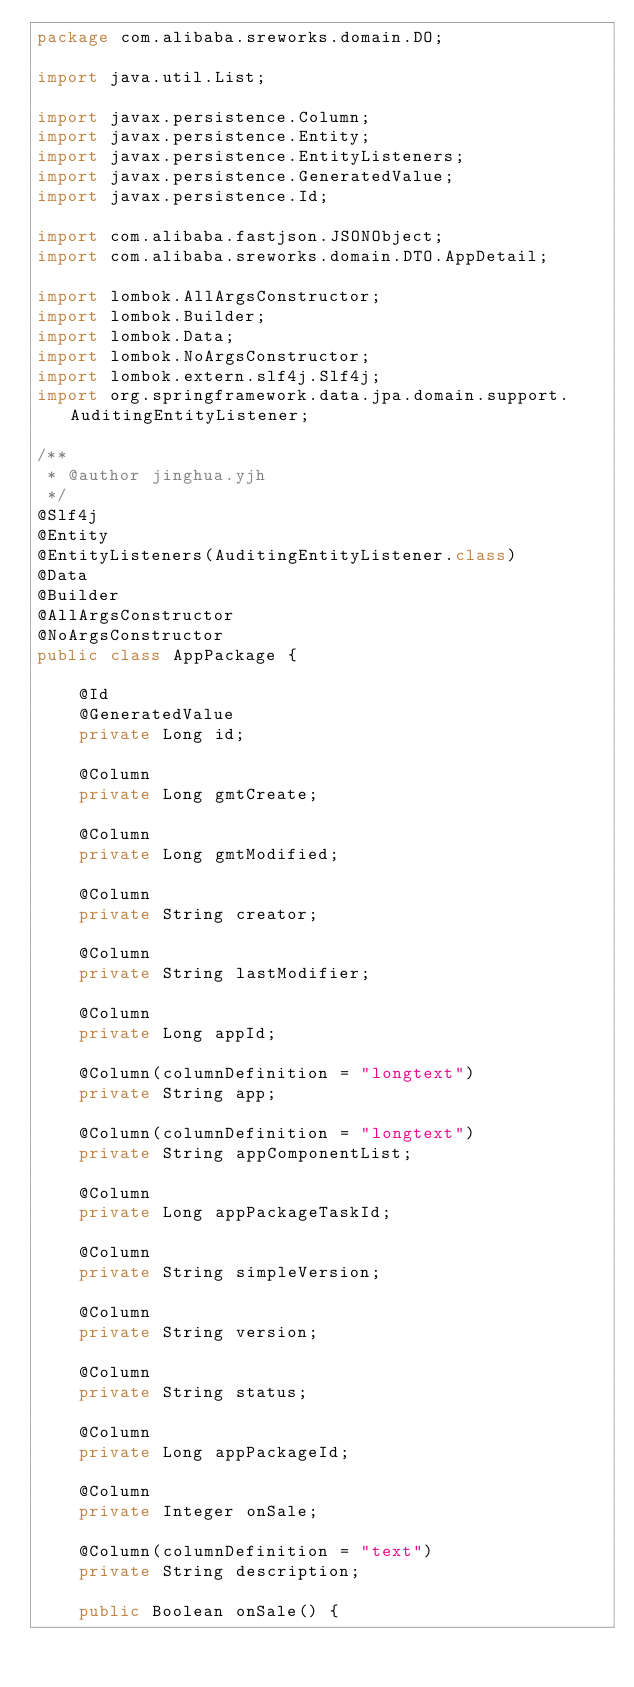Convert code to text. <code><loc_0><loc_0><loc_500><loc_500><_Java_>package com.alibaba.sreworks.domain.DO;

import java.util.List;

import javax.persistence.Column;
import javax.persistence.Entity;
import javax.persistence.EntityListeners;
import javax.persistence.GeneratedValue;
import javax.persistence.Id;

import com.alibaba.fastjson.JSONObject;
import com.alibaba.sreworks.domain.DTO.AppDetail;

import lombok.AllArgsConstructor;
import lombok.Builder;
import lombok.Data;
import lombok.NoArgsConstructor;
import lombok.extern.slf4j.Slf4j;
import org.springframework.data.jpa.domain.support.AuditingEntityListener;

/**
 * @author jinghua.yjh
 */
@Slf4j
@Entity
@EntityListeners(AuditingEntityListener.class)
@Data
@Builder
@AllArgsConstructor
@NoArgsConstructor
public class AppPackage {

    @Id
    @GeneratedValue
    private Long id;

    @Column
    private Long gmtCreate;

    @Column
    private Long gmtModified;

    @Column
    private String creator;

    @Column
    private String lastModifier;

    @Column
    private Long appId;

    @Column(columnDefinition = "longtext")
    private String app;

    @Column(columnDefinition = "longtext")
    private String appComponentList;

    @Column
    private Long appPackageTaskId;

    @Column
    private String simpleVersion;

    @Column
    private String version;

    @Column
    private String status;

    @Column
    private Long appPackageId;

    @Column
    private Integer onSale;

    @Column(columnDefinition = "text")
    private String description;

    public Boolean onSale() {</code> 